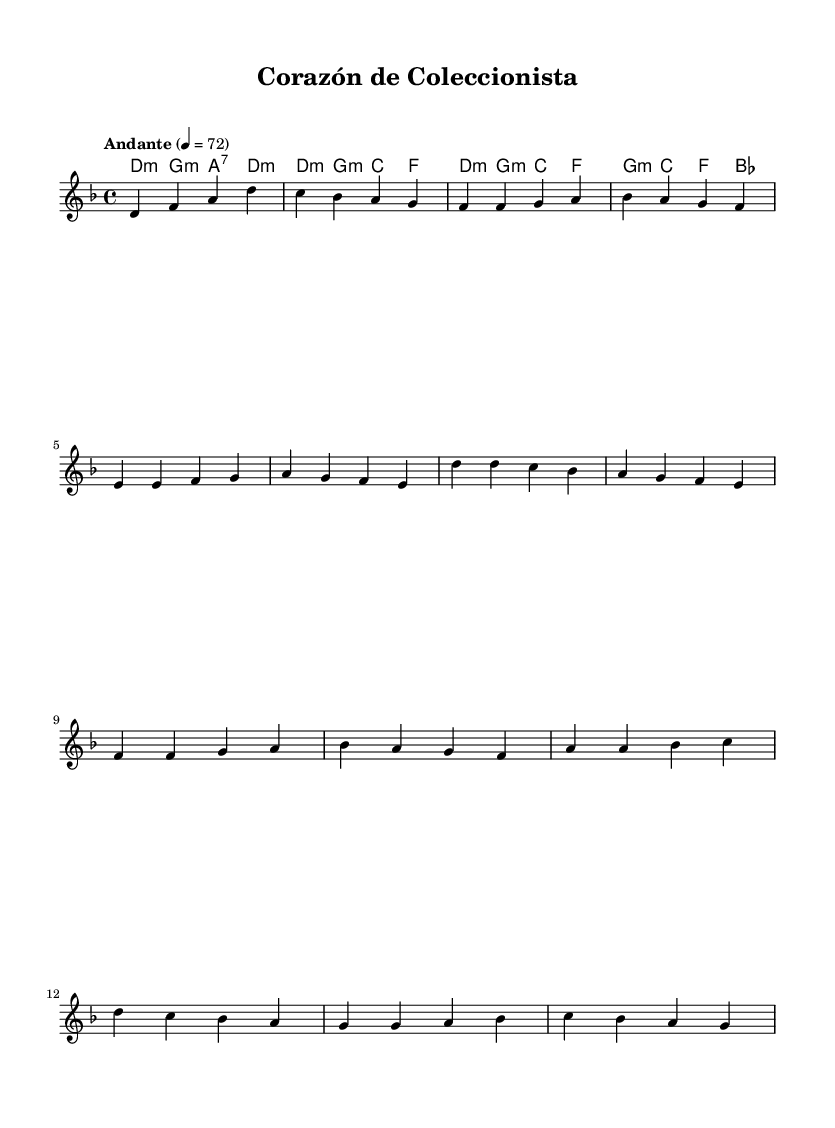What is the key signature of this music? The key signature is two flats, which indicates D minor, as the music is written in the key of D minor.
Answer: D minor What is the time signature of the piece? The time signature is located at the beginning of the score and is indicated as 4/4, which means there are four beats in each measure.
Answer: 4/4 What tempo marking is given in the score? The tempo marking is provided above the treble clef at the beginning of the piece, indicating "Andante" at a speed of quarter note equals 72 beats per minute.
Answer: Andante What is the first chord in the score? The first chord is found in the chord mode section, where it lists the chords in order; the first chord is D minor.
Answer: D minor How many measures are in the chorus section of the music? By reviewing the structure and counting the measures in the chorus section marked in the melody, we can see there are four measures total.
Answer: 4 Which musical section follows the verse? The structure of the music indicates that after the verse section, the chorus follows as a repeated and distinct part, which is a common structure in ballads.
Answer: Chorus What emotion is typically conveyed in Latin ballads? Latin ballads often convey deep emotions such as love and longing, reflecting passionate feelings which connect well to themes of dedication and admiration found in sports fandom and collecting.
Answer: Passion 